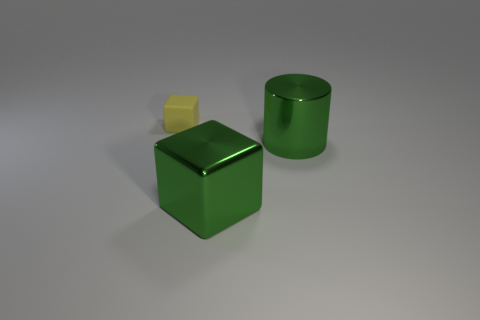How many things are big cyan rubber balls or things behind the large metallic cube?
Provide a short and direct response. 2. Is the number of big green cubes that are behind the large green block less than the number of tiny matte cubes that are behind the shiny cylinder?
Make the answer very short. Yes. What number of other things are the same material as the yellow cube?
Offer a very short reply. 0. There is a block on the right side of the yellow object; is its color the same as the cylinder?
Provide a short and direct response. Yes. Are there any tiny yellow rubber objects that are behind the green object that is on the left side of the metal cylinder?
Your answer should be very brief. Yes. There is a thing that is right of the yellow rubber thing and to the left of the green metal cylinder; what material is it?
Ensure brevity in your answer.  Metal. There is a big green thing that is the same material as the large cube; what is its shape?
Your answer should be very brief. Cylinder. Do the block that is to the right of the rubber cube and the yellow cube have the same material?
Offer a very short reply. No. There is a block that is on the right side of the small yellow rubber object; what material is it?
Ensure brevity in your answer.  Metal. There is a cube that is behind the large block that is in front of the green cylinder; how big is it?
Offer a terse response. Small. 